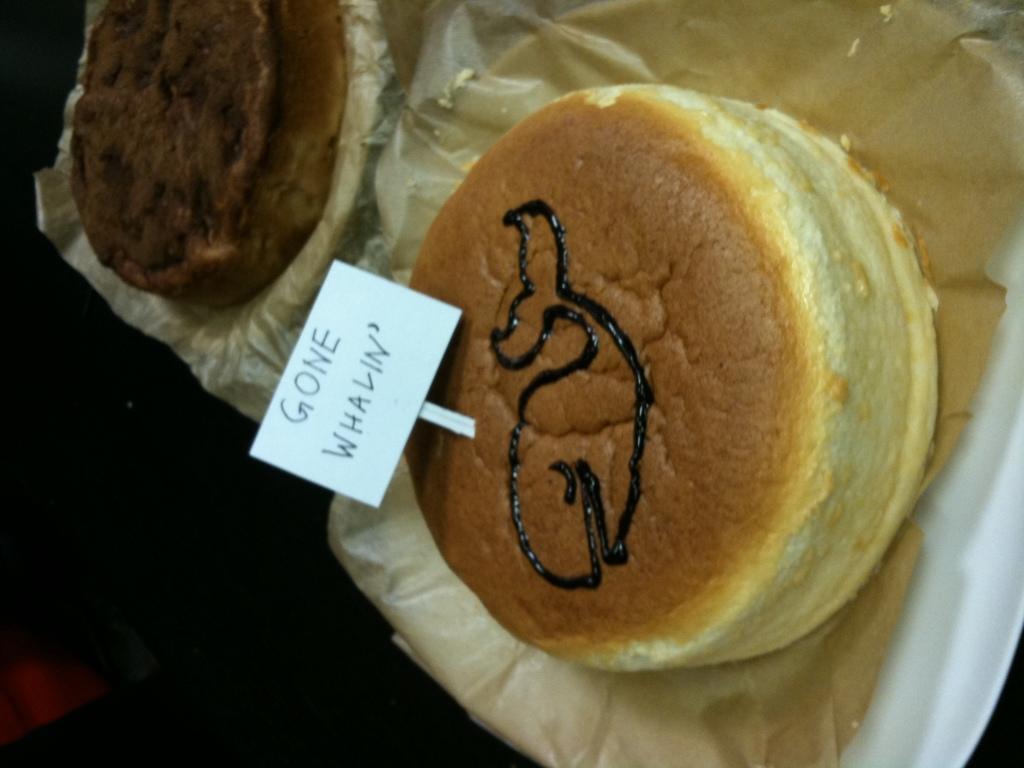Please provide a concise description of this image. In this picture we can see some food items. There is a text on a white object. 